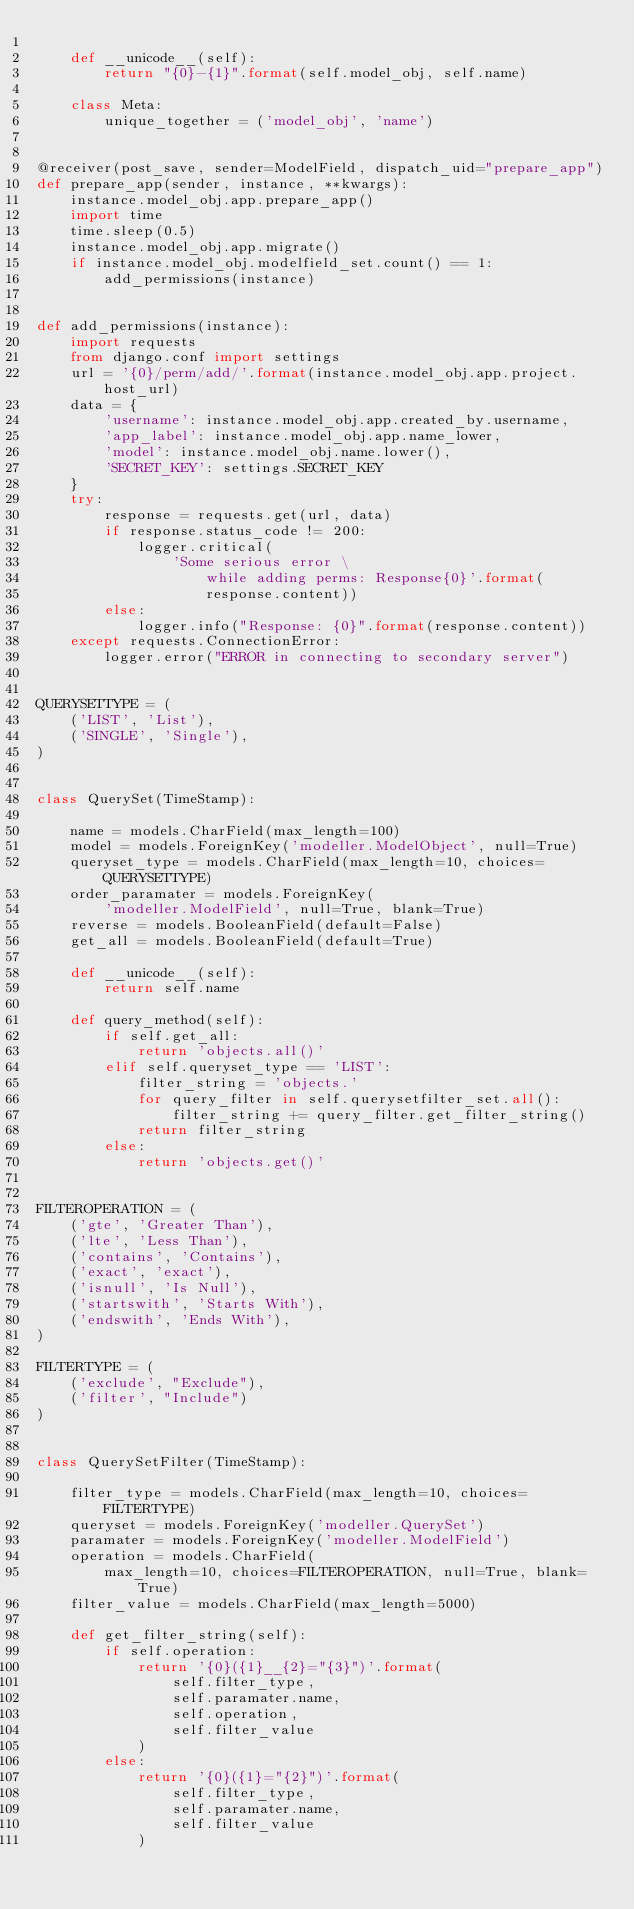Convert code to text. <code><loc_0><loc_0><loc_500><loc_500><_Python_>
    def __unicode__(self):
        return "{0}-{1}".format(self.model_obj, self.name)

    class Meta:
        unique_together = ('model_obj', 'name')


@receiver(post_save, sender=ModelField, dispatch_uid="prepare_app")
def prepare_app(sender, instance, **kwargs):
    instance.model_obj.app.prepare_app()
    import time
    time.sleep(0.5)
    instance.model_obj.app.migrate()
    if instance.model_obj.modelfield_set.count() == 1:
        add_permissions(instance)


def add_permissions(instance):
    import requests
    from django.conf import settings
    url = '{0}/perm/add/'.format(instance.model_obj.app.project.host_url)
    data = {
        'username': instance.model_obj.app.created_by.username,
        'app_label': instance.model_obj.app.name_lower,
        'model': instance.model_obj.name.lower(),
        'SECRET_KEY': settings.SECRET_KEY
    }
    try:
        response = requests.get(url, data)
        if response.status_code != 200:
            logger.critical(
                'Some serious error \
                    while adding perms: Response{0}'.format(
                    response.content))
        else:
            logger.info("Response: {0}".format(response.content))
    except requests.ConnectionError:
        logger.error("ERROR in connecting to secondary server")


QUERYSETTYPE = (
    ('LIST', 'List'),
    ('SINGLE', 'Single'),
)


class QuerySet(TimeStamp):

    name = models.CharField(max_length=100)
    model = models.ForeignKey('modeller.ModelObject', null=True)
    queryset_type = models.CharField(max_length=10, choices=QUERYSETTYPE)
    order_paramater = models.ForeignKey(
        'modeller.ModelField', null=True, blank=True)
    reverse = models.BooleanField(default=False)
    get_all = models.BooleanField(default=True)

    def __unicode__(self):
        return self.name

    def query_method(self):
        if self.get_all:
            return 'objects.all()'
        elif self.queryset_type == 'LIST':
            filter_string = 'objects.'
            for query_filter in self.querysetfilter_set.all():
                filter_string += query_filter.get_filter_string()
            return filter_string
        else:
            return 'objects.get()'


FILTEROPERATION = (
    ('gte', 'Greater Than'),
    ('lte', 'Less Than'),
    ('contains', 'Contains'),
    ('exact', 'exact'),
    ('isnull', 'Is Null'),
    ('startswith', 'Starts With'),
    ('endswith', 'Ends With'),
)

FILTERTYPE = (
    ('exclude', "Exclude"),
    ('filter', "Include")
)


class QuerySetFilter(TimeStamp):

    filter_type = models.CharField(max_length=10, choices=FILTERTYPE)
    queryset = models.ForeignKey('modeller.QuerySet')
    paramater = models.ForeignKey('modeller.ModelField')
    operation = models.CharField(
        max_length=10, choices=FILTEROPERATION, null=True, blank=True)
    filter_value = models.CharField(max_length=5000)

    def get_filter_string(self):
        if self.operation:
            return '{0}({1}__{2}="{3}")'.format(
                self.filter_type,
                self.paramater.name,
                self.operation,
                self.filter_value
            )
        else:
            return '{0}({1}="{2}")'.format(
                self.filter_type,
                self.paramater.name,
                self.filter_value
            )



</code> 